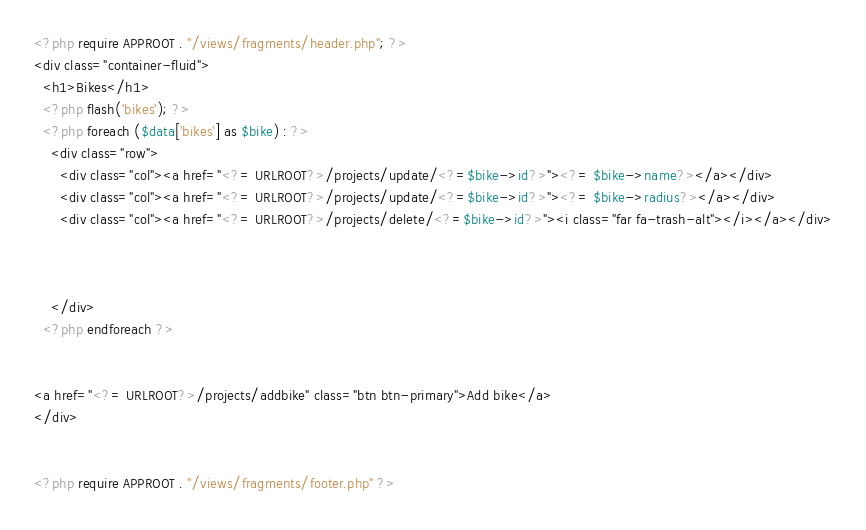Convert code to text. <code><loc_0><loc_0><loc_500><loc_500><_PHP_><?php require APPROOT . "/views/fragments/header.php"; ?>
<div class="container-fluid">
  <h1>Bikes</h1>
  <?php flash('bikes'); ?>
  <?php foreach ($data['bikes'] as $bike) : ?>
    <div class="row">
      <div class="col"><a href="<?= URLROOT?>/projects/update/<?=$bike->id?>"><?= $bike->name?></a></div>
      <div class="col"><a href="<?= URLROOT?>/projects/update/<?=$bike->id?>"><?= $bike->radius?></a></div>
      <div class="col"><a href="<?= URLROOT?>/projects/delete/<?=$bike->id?>"><i class="far fa-trash-alt"></i></a></div>
  
  
   
    </div>
  <?php endforeach ?>

  
<a href="<?= URLROOT?>/projects/addbike" class="btn btn-primary">Add bike</a>
</div>


<?php require APPROOT . "/views/fragments/footer.php" ?></code> 